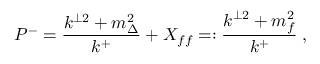<formula> <loc_0><loc_0><loc_500><loc_500>P ^ { - } = \frac { k ^ { \perp 2 } + m _ { \Delta } ^ { 2 } } { k ^ { + } } + X _ { f f } = \colon \frac { k ^ { \perp 2 } + m _ { f } ^ { 2 } } { k ^ { + } } \, ,</formula> 